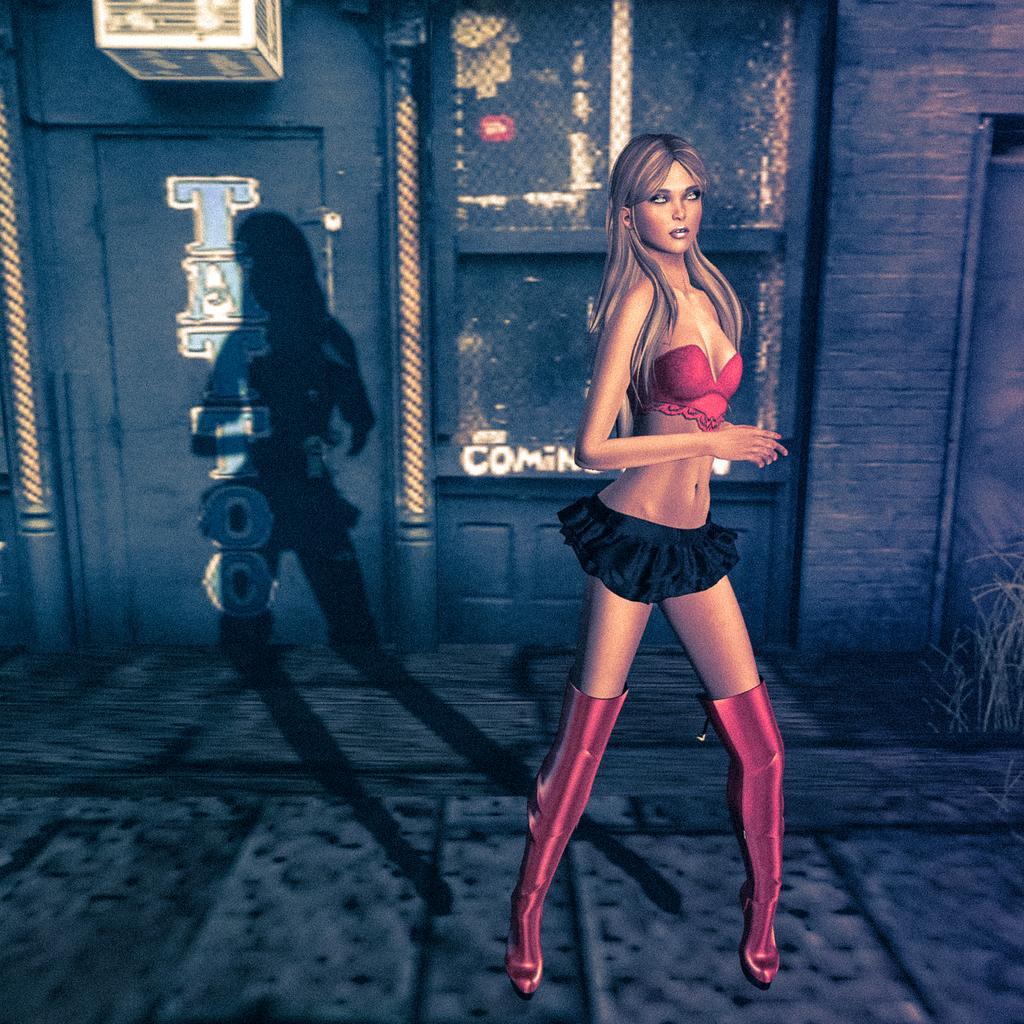Please provide a concise description of this image. In this picture I can see animation of a woman. In the background I can see wall and shadow of a woman. I can also see a name on the wall and white color object. 